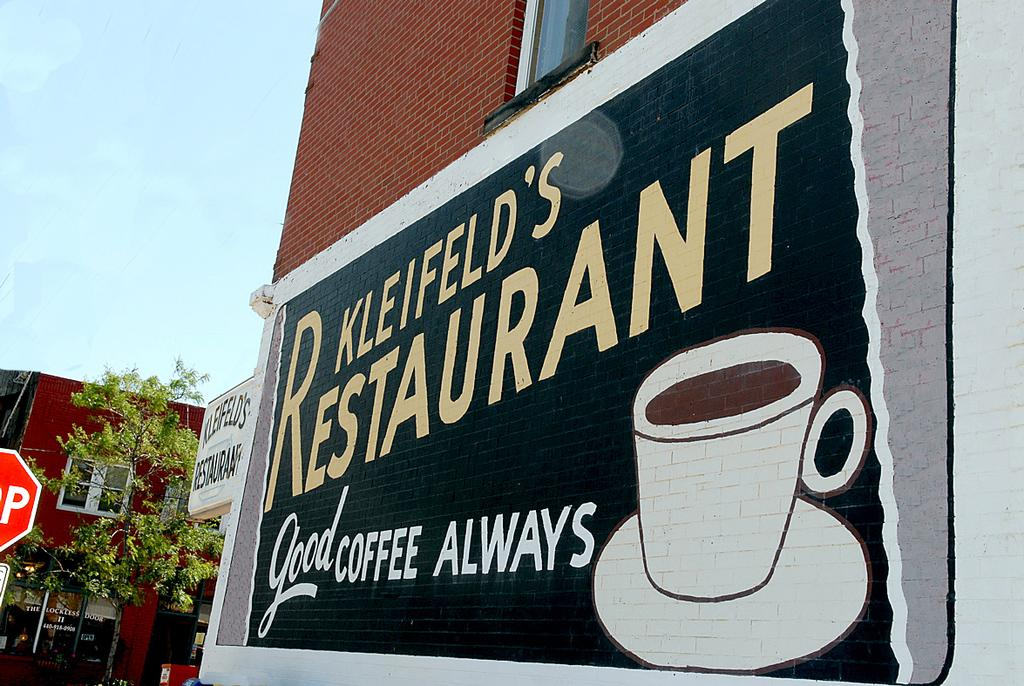What type of structures can be seen in the image? There are buildings in the image. What else is present in the image besides the buildings? There are boards and trees visible in the image. Can you describe the artwork in the image? There is a painting on one of the buildings. What can be seen in the background of the image? The sky is visible in the background of the image. Who is the creator of the patch on the board in the image? There is no patch present on the board in the image. 